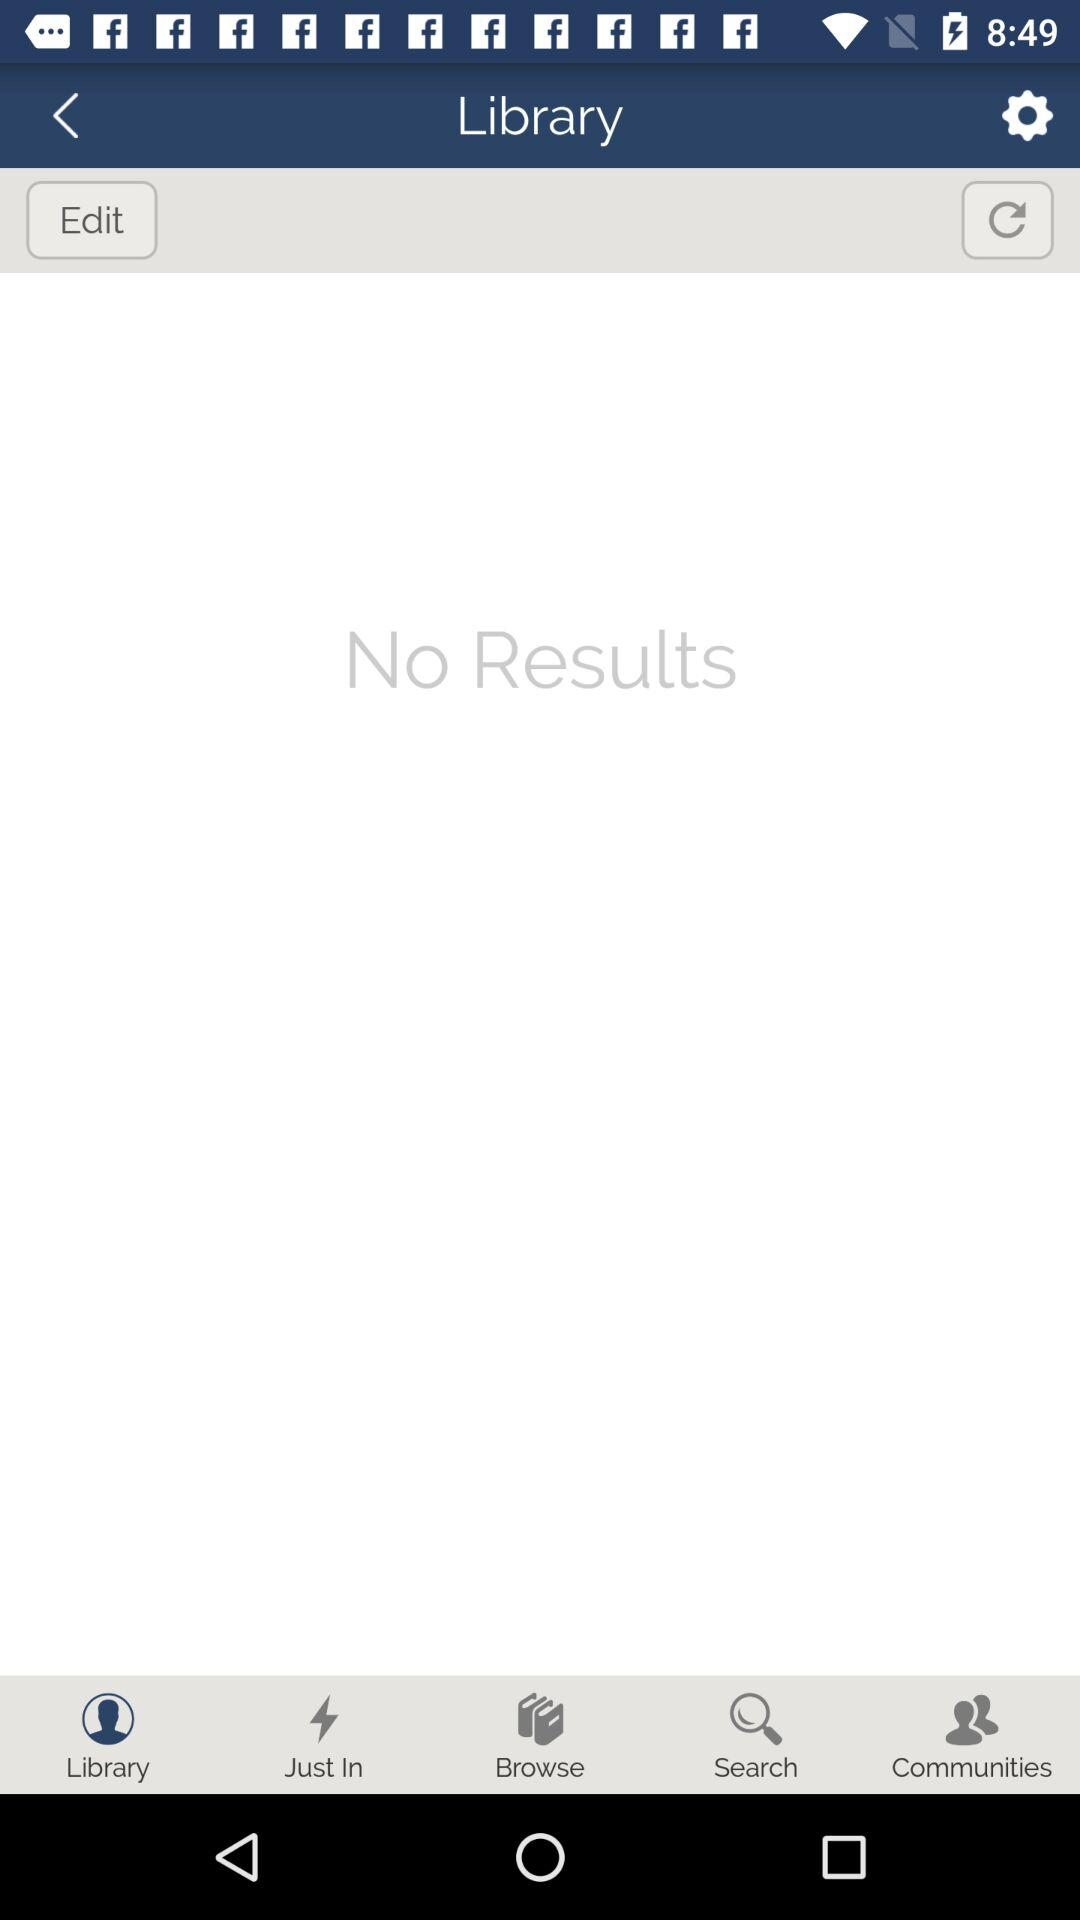What is the application name?
When the provided information is insufficient, respond with <no answer>. <no answer> 